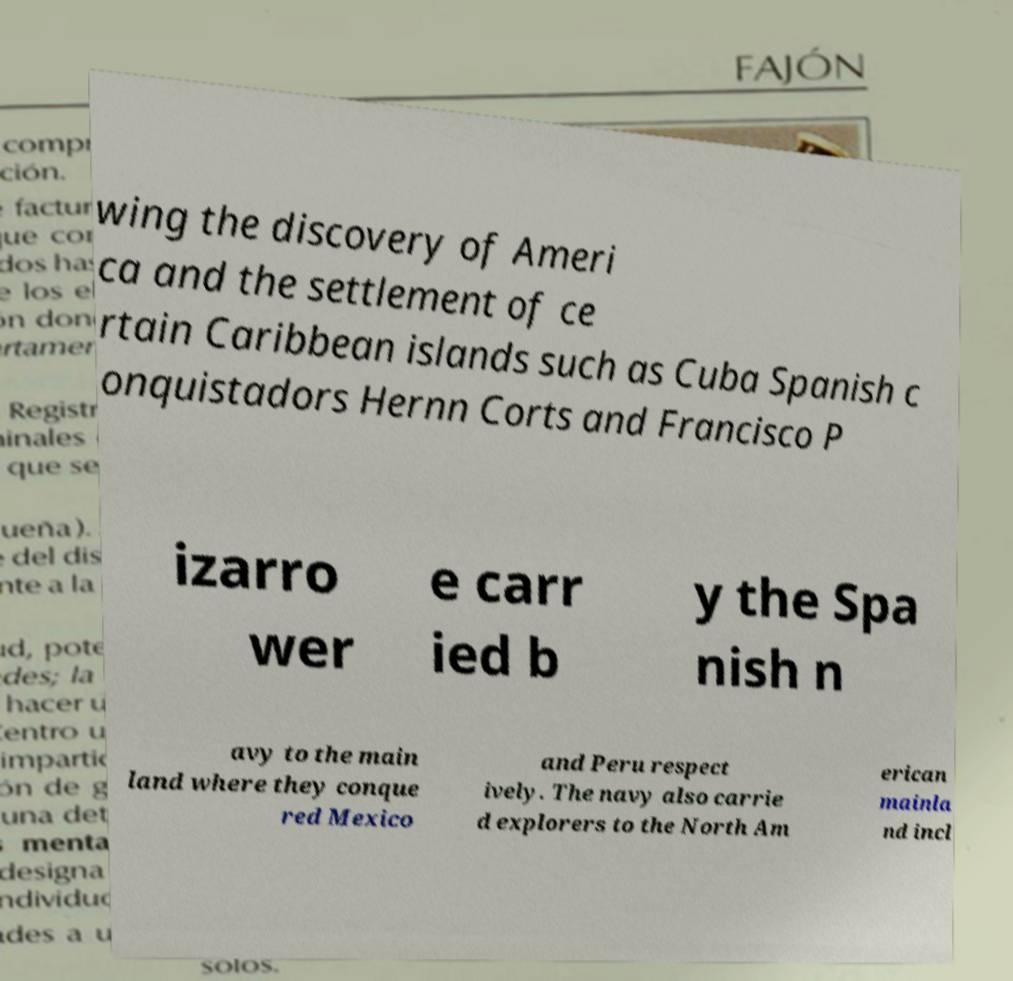Please read and relay the text visible in this image. What does it say? wing the discovery of Ameri ca and the settlement of ce rtain Caribbean islands such as Cuba Spanish c onquistadors Hernn Corts and Francisco P izarro wer e carr ied b y the Spa nish n avy to the main land where they conque red Mexico and Peru respect ively. The navy also carrie d explorers to the North Am erican mainla nd incl 